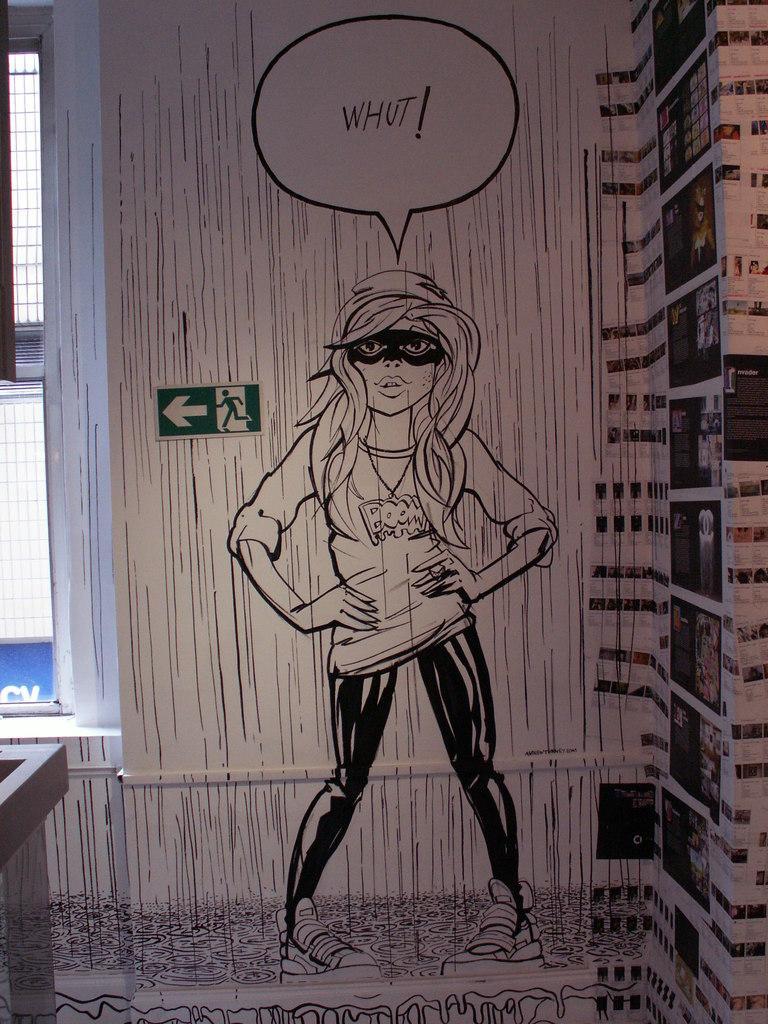Could you give a brief overview of what you see in this image? This is a picture of a wall, on the wall there is a painting of a woman. On the right on the wall there are photographs. On the left of the picture there are windows. 